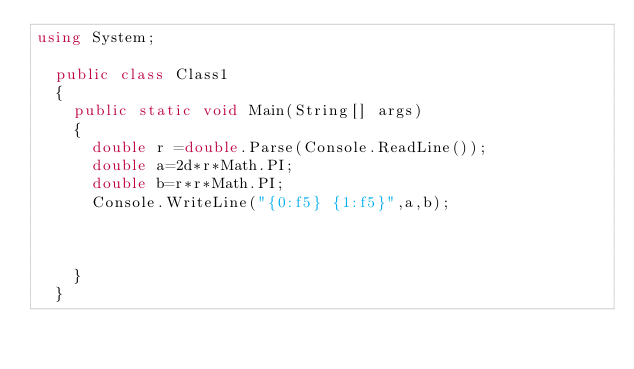Convert code to text. <code><loc_0><loc_0><loc_500><loc_500><_C#_>using System;

	public class Class1
	{
		public static void Main(String[] args)
		{
			double r =double.Parse(Console.ReadLine());
			double a=2d*r*Math.PI;
			double b=r*r*Math.PI;
			Console.WriteLine("{0:f5} {1:f5}",a,b);
			
			
			
		}
	}</code> 